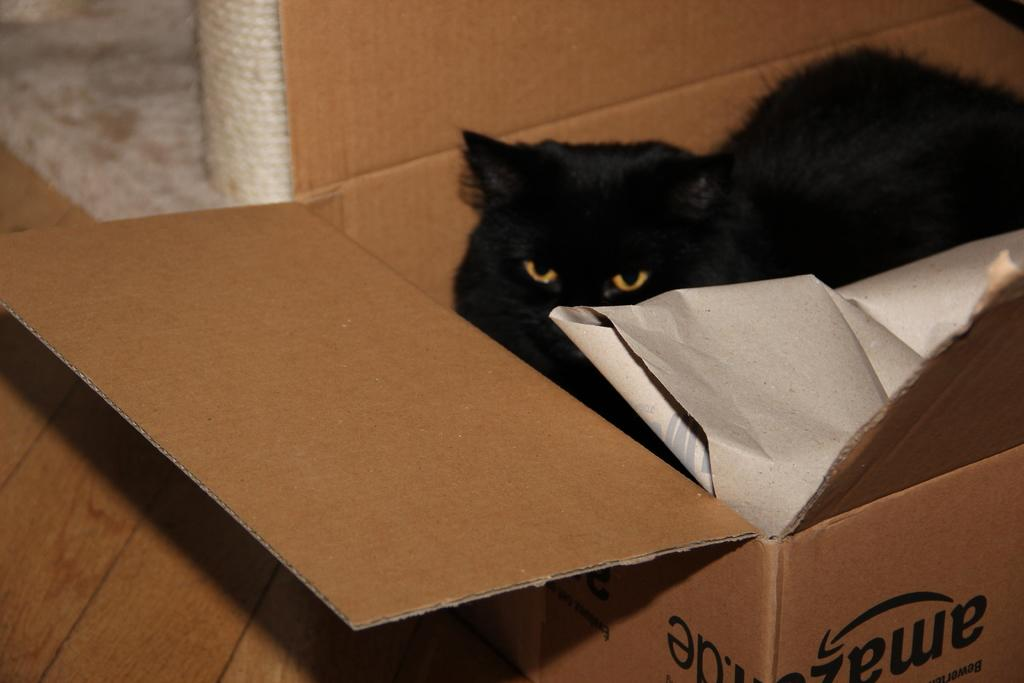What type of animal is in the image? There is a black color cat in the image. Where is the cat located? The cat is in a cardboard box. What other object can be seen in the image? There is a white color paper in the image. How does the cat compare to the bread in the image? There is no bread present in the image, so it cannot be compared to the cat. 